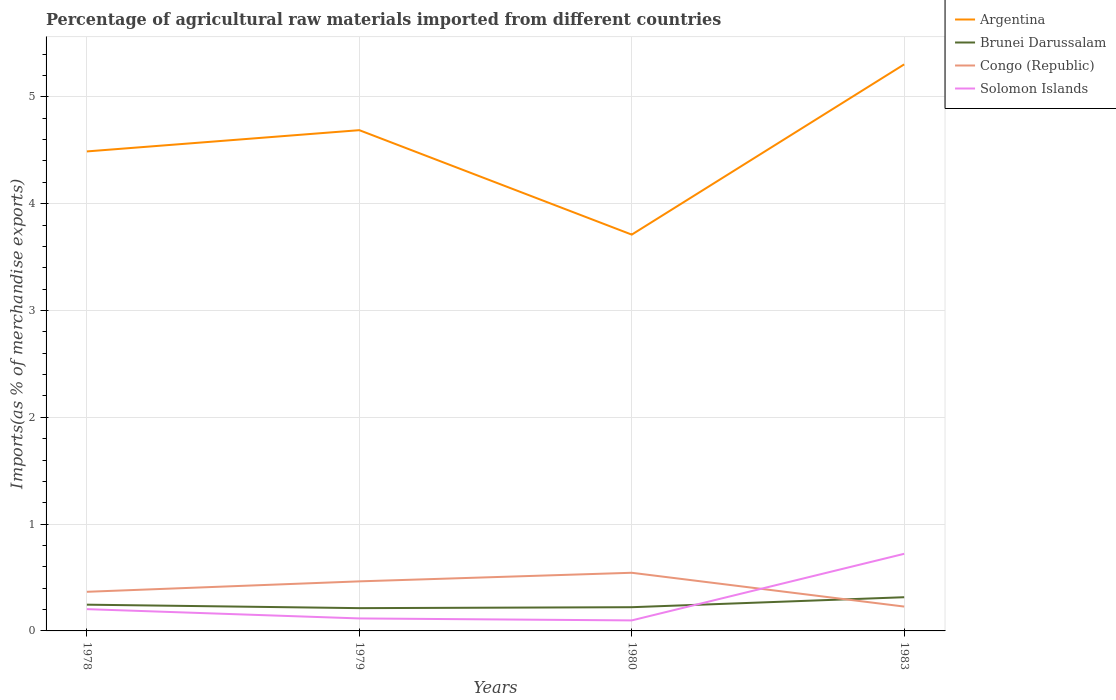How many different coloured lines are there?
Your answer should be compact. 4. Does the line corresponding to Argentina intersect with the line corresponding to Brunei Darussalam?
Offer a terse response. No. Across all years, what is the maximum percentage of imports to different countries in Solomon Islands?
Keep it short and to the point. 0.1. In which year was the percentage of imports to different countries in Brunei Darussalam maximum?
Make the answer very short. 1979. What is the total percentage of imports to different countries in Argentina in the graph?
Your answer should be very brief. -1.59. What is the difference between the highest and the second highest percentage of imports to different countries in Brunei Darussalam?
Keep it short and to the point. 0.1. Is the percentage of imports to different countries in Solomon Islands strictly greater than the percentage of imports to different countries in Congo (Republic) over the years?
Ensure brevity in your answer.  No. How many years are there in the graph?
Offer a very short reply. 4. Does the graph contain any zero values?
Ensure brevity in your answer.  No. Does the graph contain grids?
Ensure brevity in your answer.  Yes. How many legend labels are there?
Offer a very short reply. 4. What is the title of the graph?
Keep it short and to the point. Percentage of agricultural raw materials imported from different countries. What is the label or title of the X-axis?
Give a very brief answer. Years. What is the label or title of the Y-axis?
Give a very brief answer. Imports(as % of merchandise exports). What is the Imports(as % of merchandise exports) in Argentina in 1978?
Offer a very short reply. 4.49. What is the Imports(as % of merchandise exports) of Brunei Darussalam in 1978?
Offer a terse response. 0.25. What is the Imports(as % of merchandise exports) in Congo (Republic) in 1978?
Keep it short and to the point. 0.37. What is the Imports(as % of merchandise exports) of Solomon Islands in 1978?
Your response must be concise. 0.2. What is the Imports(as % of merchandise exports) of Argentina in 1979?
Your answer should be very brief. 4.69. What is the Imports(as % of merchandise exports) in Brunei Darussalam in 1979?
Your answer should be compact. 0.21. What is the Imports(as % of merchandise exports) of Congo (Republic) in 1979?
Your answer should be very brief. 0.46. What is the Imports(as % of merchandise exports) in Solomon Islands in 1979?
Give a very brief answer. 0.12. What is the Imports(as % of merchandise exports) in Argentina in 1980?
Your answer should be very brief. 3.71. What is the Imports(as % of merchandise exports) of Brunei Darussalam in 1980?
Ensure brevity in your answer.  0.22. What is the Imports(as % of merchandise exports) in Congo (Republic) in 1980?
Provide a succinct answer. 0.54. What is the Imports(as % of merchandise exports) of Solomon Islands in 1980?
Offer a very short reply. 0.1. What is the Imports(as % of merchandise exports) of Argentina in 1983?
Your answer should be compact. 5.3. What is the Imports(as % of merchandise exports) of Brunei Darussalam in 1983?
Your answer should be very brief. 0.32. What is the Imports(as % of merchandise exports) of Congo (Republic) in 1983?
Make the answer very short. 0.23. What is the Imports(as % of merchandise exports) of Solomon Islands in 1983?
Offer a very short reply. 0.72. Across all years, what is the maximum Imports(as % of merchandise exports) in Argentina?
Your answer should be very brief. 5.3. Across all years, what is the maximum Imports(as % of merchandise exports) in Brunei Darussalam?
Your answer should be compact. 0.32. Across all years, what is the maximum Imports(as % of merchandise exports) of Congo (Republic)?
Ensure brevity in your answer.  0.54. Across all years, what is the maximum Imports(as % of merchandise exports) in Solomon Islands?
Give a very brief answer. 0.72. Across all years, what is the minimum Imports(as % of merchandise exports) of Argentina?
Offer a very short reply. 3.71. Across all years, what is the minimum Imports(as % of merchandise exports) in Brunei Darussalam?
Offer a very short reply. 0.21. Across all years, what is the minimum Imports(as % of merchandise exports) in Congo (Republic)?
Keep it short and to the point. 0.23. Across all years, what is the minimum Imports(as % of merchandise exports) in Solomon Islands?
Provide a short and direct response. 0.1. What is the total Imports(as % of merchandise exports) in Argentina in the graph?
Your answer should be very brief. 18.19. What is the total Imports(as % of merchandise exports) in Congo (Republic) in the graph?
Make the answer very short. 1.6. What is the total Imports(as % of merchandise exports) of Solomon Islands in the graph?
Offer a very short reply. 1.14. What is the difference between the Imports(as % of merchandise exports) in Argentina in 1978 and that in 1979?
Make the answer very short. -0.2. What is the difference between the Imports(as % of merchandise exports) in Brunei Darussalam in 1978 and that in 1979?
Your answer should be very brief. 0.03. What is the difference between the Imports(as % of merchandise exports) of Congo (Republic) in 1978 and that in 1979?
Offer a very short reply. -0.1. What is the difference between the Imports(as % of merchandise exports) of Solomon Islands in 1978 and that in 1979?
Ensure brevity in your answer.  0.09. What is the difference between the Imports(as % of merchandise exports) in Argentina in 1978 and that in 1980?
Keep it short and to the point. 0.78. What is the difference between the Imports(as % of merchandise exports) of Brunei Darussalam in 1978 and that in 1980?
Make the answer very short. 0.02. What is the difference between the Imports(as % of merchandise exports) in Congo (Republic) in 1978 and that in 1980?
Give a very brief answer. -0.18. What is the difference between the Imports(as % of merchandise exports) of Solomon Islands in 1978 and that in 1980?
Make the answer very short. 0.11. What is the difference between the Imports(as % of merchandise exports) in Argentina in 1978 and that in 1983?
Your answer should be compact. -0.81. What is the difference between the Imports(as % of merchandise exports) in Brunei Darussalam in 1978 and that in 1983?
Your answer should be compact. -0.07. What is the difference between the Imports(as % of merchandise exports) of Congo (Republic) in 1978 and that in 1983?
Offer a very short reply. 0.14. What is the difference between the Imports(as % of merchandise exports) of Solomon Islands in 1978 and that in 1983?
Offer a terse response. -0.52. What is the difference between the Imports(as % of merchandise exports) in Argentina in 1979 and that in 1980?
Provide a short and direct response. 0.98. What is the difference between the Imports(as % of merchandise exports) in Brunei Darussalam in 1979 and that in 1980?
Give a very brief answer. -0.01. What is the difference between the Imports(as % of merchandise exports) in Congo (Republic) in 1979 and that in 1980?
Your answer should be compact. -0.08. What is the difference between the Imports(as % of merchandise exports) in Solomon Islands in 1979 and that in 1980?
Offer a very short reply. 0.02. What is the difference between the Imports(as % of merchandise exports) in Argentina in 1979 and that in 1983?
Give a very brief answer. -0.62. What is the difference between the Imports(as % of merchandise exports) of Brunei Darussalam in 1979 and that in 1983?
Keep it short and to the point. -0.1. What is the difference between the Imports(as % of merchandise exports) in Congo (Republic) in 1979 and that in 1983?
Keep it short and to the point. 0.24. What is the difference between the Imports(as % of merchandise exports) in Solomon Islands in 1979 and that in 1983?
Keep it short and to the point. -0.61. What is the difference between the Imports(as % of merchandise exports) of Argentina in 1980 and that in 1983?
Offer a terse response. -1.59. What is the difference between the Imports(as % of merchandise exports) of Brunei Darussalam in 1980 and that in 1983?
Make the answer very short. -0.09. What is the difference between the Imports(as % of merchandise exports) in Congo (Republic) in 1980 and that in 1983?
Make the answer very short. 0.32. What is the difference between the Imports(as % of merchandise exports) of Solomon Islands in 1980 and that in 1983?
Provide a succinct answer. -0.62. What is the difference between the Imports(as % of merchandise exports) of Argentina in 1978 and the Imports(as % of merchandise exports) of Brunei Darussalam in 1979?
Your response must be concise. 4.28. What is the difference between the Imports(as % of merchandise exports) in Argentina in 1978 and the Imports(as % of merchandise exports) in Congo (Republic) in 1979?
Your response must be concise. 4.03. What is the difference between the Imports(as % of merchandise exports) of Argentina in 1978 and the Imports(as % of merchandise exports) of Solomon Islands in 1979?
Make the answer very short. 4.37. What is the difference between the Imports(as % of merchandise exports) of Brunei Darussalam in 1978 and the Imports(as % of merchandise exports) of Congo (Republic) in 1979?
Your answer should be compact. -0.22. What is the difference between the Imports(as % of merchandise exports) of Brunei Darussalam in 1978 and the Imports(as % of merchandise exports) of Solomon Islands in 1979?
Your answer should be very brief. 0.13. What is the difference between the Imports(as % of merchandise exports) in Congo (Republic) in 1978 and the Imports(as % of merchandise exports) in Solomon Islands in 1979?
Make the answer very short. 0.25. What is the difference between the Imports(as % of merchandise exports) of Argentina in 1978 and the Imports(as % of merchandise exports) of Brunei Darussalam in 1980?
Provide a short and direct response. 4.27. What is the difference between the Imports(as % of merchandise exports) of Argentina in 1978 and the Imports(as % of merchandise exports) of Congo (Republic) in 1980?
Your answer should be very brief. 3.95. What is the difference between the Imports(as % of merchandise exports) of Argentina in 1978 and the Imports(as % of merchandise exports) of Solomon Islands in 1980?
Offer a very short reply. 4.39. What is the difference between the Imports(as % of merchandise exports) of Brunei Darussalam in 1978 and the Imports(as % of merchandise exports) of Congo (Republic) in 1980?
Provide a succinct answer. -0.3. What is the difference between the Imports(as % of merchandise exports) of Brunei Darussalam in 1978 and the Imports(as % of merchandise exports) of Solomon Islands in 1980?
Provide a short and direct response. 0.15. What is the difference between the Imports(as % of merchandise exports) of Congo (Republic) in 1978 and the Imports(as % of merchandise exports) of Solomon Islands in 1980?
Make the answer very short. 0.27. What is the difference between the Imports(as % of merchandise exports) in Argentina in 1978 and the Imports(as % of merchandise exports) in Brunei Darussalam in 1983?
Your response must be concise. 4.17. What is the difference between the Imports(as % of merchandise exports) of Argentina in 1978 and the Imports(as % of merchandise exports) of Congo (Republic) in 1983?
Offer a terse response. 4.26. What is the difference between the Imports(as % of merchandise exports) in Argentina in 1978 and the Imports(as % of merchandise exports) in Solomon Islands in 1983?
Your response must be concise. 3.77. What is the difference between the Imports(as % of merchandise exports) in Brunei Darussalam in 1978 and the Imports(as % of merchandise exports) in Congo (Republic) in 1983?
Offer a very short reply. 0.02. What is the difference between the Imports(as % of merchandise exports) of Brunei Darussalam in 1978 and the Imports(as % of merchandise exports) of Solomon Islands in 1983?
Your answer should be very brief. -0.48. What is the difference between the Imports(as % of merchandise exports) of Congo (Republic) in 1978 and the Imports(as % of merchandise exports) of Solomon Islands in 1983?
Keep it short and to the point. -0.36. What is the difference between the Imports(as % of merchandise exports) of Argentina in 1979 and the Imports(as % of merchandise exports) of Brunei Darussalam in 1980?
Give a very brief answer. 4.47. What is the difference between the Imports(as % of merchandise exports) of Argentina in 1979 and the Imports(as % of merchandise exports) of Congo (Republic) in 1980?
Your answer should be compact. 4.14. What is the difference between the Imports(as % of merchandise exports) in Argentina in 1979 and the Imports(as % of merchandise exports) in Solomon Islands in 1980?
Ensure brevity in your answer.  4.59. What is the difference between the Imports(as % of merchandise exports) of Brunei Darussalam in 1979 and the Imports(as % of merchandise exports) of Congo (Republic) in 1980?
Offer a very short reply. -0.33. What is the difference between the Imports(as % of merchandise exports) of Brunei Darussalam in 1979 and the Imports(as % of merchandise exports) of Solomon Islands in 1980?
Provide a succinct answer. 0.11. What is the difference between the Imports(as % of merchandise exports) in Congo (Republic) in 1979 and the Imports(as % of merchandise exports) in Solomon Islands in 1980?
Ensure brevity in your answer.  0.37. What is the difference between the Imports(as % of merchandise exports) in Argentina in 1979 and the Imports(as % of merchandise exports) in Brunei Darussalam in 1983?
Provide a short and direct response. 4.37. What is the difference between the Imports(as % of merchandise exports) in Argentina in 1979 and the Imports(as % of merchandise exports) in Congo (Republic) in 1983?
Ensure brevity in your answer.  4.46. What is the difference between the Imports(as % of merchandise exports) of Argentina in 1979 and the Imports(as % of merchandise exports) of Solomon Islands in 1983?
Keep it short and to the point. 3.97. What is the difference between the Imports(as % of merchandise exports) in Brunei Darussalam in 1979 and the Imports(as % of merchandise exports) in Congo (Republic) in 1983?
Keep it short and to the point. -0.01. What is the difference between the Imports(as % of merchandise exports) of Brunei Darussalam in 1979 and the Imports(as % of merchandise exports) of Solomon Islands in 1983?
Offer a terse response. -0.51. What is the difference between the Imports(as % of merchandise exports) of Congo (Republic) in 1979 and the Imports(as % of merchandise exports) of Solomon Islands in 1983?
Provide a short and direct response. -0.26. What is the difference between the Imports(as % of merchandise exports) in Argentina in 1980 and the Imports(as % of merchandise exports) in Brunei Darussalam in 1983?
Your answer should be compact. 3.4. What is the difference between the Imports(as % of merchandise exports) in Argentina in 1980 and the Imports(as % of merchandise exports) in Congo (Republic) in 1983?
Your answer should be compact. 3.48. What is the difference between the Imports(as % of merchandise exports) in Argentina in 1980 and the Imports(as % of merchandise exports) in Solomon Islands in 1983?
Your answer should be very brief. 2.99. What is the difference between the Imports(as % of merchandise exports) in Brunei Darussalam in 1980 and the Imports(as % of merchandise exports) in Congo (Republic) in 1983?
Make the answer very short. -0.01. What is the difference between the Imports(as % of merchandise exports) of Congo (Republic) in 1980 and the Imports(as % of merchandise exports) of Solomon Islands in 1983?
Offer a very short reply. -0.18. What is the average Imports(as % of merchandise exports) of Argentina per year?
Make the answer very short. 4.55. What is the average Imports(as % of merchandise exports) in Brunei Darussalam per year?
Your response must be concise. 0.25. What is the average Imports(as % of merchandise exports) of Congo (Republic) per year?
Your response must be concise. 0.4. What is the average Imports(as % of merchandise exports) in Solomon Islands per year?
Offer a very short reply. 0.29. In the year 1978, what is the difference between the Imports(as % of merchandise exports) in Argentina and Imports(as % of merchandise exports) in Brunei Darussalam?
Keep it short and to the point. 4.24. In the year 1978, what is the difference between the Imports(as % of merchandise exports) in Argentina and Imports(as % of merchandise exports) in Congo (Republic)?
Offer a very short reply. 4.12. In the year 1978, what is the difference between the Imports(as % of merchandise exports) of Argentina and Imports(as % of merchandise exports) of Solomon Islands?
Make the answer very short. 4.29. In the year 1978, what is the difference between the Imports(as % of merchandise exports) in Brunei Darussalam and Imports(as % of merchandise exports) in Congo (Republic)?
Provide a short and direct response. -0.12. In the year 1978, what is the difference between the Imports(as % of merchandise exports) of Brunei Darussalam and Imports(as % of merchandise exports) of Solomon Islands?
Give a very brief answer. 0.04. In the year 1978, what is the difference between the Imports(as % of merchandise exports) of Congo (Republic) and Imports(as % of merchandise exports) of Solomon Islands?
Offer a terse response. 0.16. In the year 1979, what is the difference between the Imports(as % of merchandise exports) of Argentina and Imports(as % of merchandise exports) of Brunei Darussalam?
Your answer should be very brief. 4.48. In the year 1979, what is the difference between the Imports(as % of merchandise exports) in Argentina and Imports(as % of merchandise exports) in Congo (Republic)?
Provide a short and direct response. 4.22. In the year 1979, what is the difference between the Imports(as % of merchandise exports) in Argentina and Imports(as % of merchandise exports) in Solomon Islands?
Give a very brief answer. 4.57. In the year 1979, what is the difference between the Imports(as % of merchandise exports) of Brunei Darussalam and Imports(as % of merchandise exports) of Congo (Republic)?
Your answer should be very brief. -0.25. In the year 1979, what is the difference between the Imports(as % of merchandise exports) in Brunei Darussalam and Imports(as % of merchandise exports) in Solomon Islands?
Your answer should be compact. 0.1. In the year 1979, what is the difference between the Imports(as % of merchandise exports) of Congo (Republic) and Imports(as % of merchandise exports) of Solomon Islands?
Your answer should be very brief. 0.35. In the year 1980, what is the difference between the Imports(as % of merchandise exports) of Argentina and Imports(as % of merchandise exports) of Brunei Darussalam?
Offer a terse response. 3.49. In the year 1980, what is the difference between the Imports(as % of merchandise exports) in Argentina and Imports(as % of merchandise exports) in Congo (Republic)?
Provide a short and direct response. 3.17. In the year 1980, what is the difference between the Imports(as % of merchandise exports) of Argentina and Imports(as % of merchandise exports) of Solomon Islands?
Your response must be concise. 3.61. In the year 1980, what is the difference between the Imports(as % of merchandise exports) of Brunei Darussalam and Imports(as % of merchandise exports) of Congo (Republic)?
Give a very brief answer. -0.32. In the year 1980, what is the difference between the Imports(as % of merchandise exports) of Brunei Darussalam and Imports(as % of merchandise exports) of Solomon Islands?
Your answer should be very brief. 0.12. In the year 1980, what is the difference between the Imports(as % of merchandise exports) of Congo (Republic) and Imports(as % of merchandise exports) of Solomon Islands?
Your response must be concise. 0.45. In the year 1983, what is the difference between the Imports(as % of merchandise exports) in Argentina and Imports(as % of merchandise exports) in Brunei Darussalam?
Make the answer very short. 4.99. In the year 1983, what is the difference between the Imports(as % of merchandise exports) in Argentina and Imports(as % of merchandise exports) in Congo (Republic)?
Provide a short and direct response. 5.08. In the year 1983, what is the difference between the Imports(as % of merchandise exports) in Argentina and Imports(as % of merchandise exports) in Solomon Islands?
Your answer should be very brief. 4.58. In the year 1983, what is the difference between the Imports(as % of merchandise exports) in Brunei Darussalam and Imports(as % of merchandise exports) in Congo (Republic)?
Ensure brevity in your answer.  0.09. In the year 1983, what is the difference between the Imports(as % of merchandise exports) of Brunei Darussalam and Imports(as % of merchandise exports) of Solomon Islands?
Your answer should be very brief. -0.41. In the year 1983, what is the difference between the Imports(as % of merchandise exports) of Congo (Republic) and Imports(as % of merchandise exports) of Solomon Islands?
Make the answer very short. -0.49. What is the ratio of the Imports(as % of merchandise exports) of Argentina in 1978 to that in 1979?
Keep it short and to the point. 0.96. What is the ratio of the Imports(as % of merchandise exports) of Brunei Darussalam in 1978 to that in 1979?
Your response must be concise. 1.15. What is the ratio of the Imports(as % of merchandise exports) of Congo (Republic) in 1978 to that in 1979?
Make the answer very short. 0.79. What is the ratio of the Imports(as % of merchandise exports) of Solomon Islands in 1978 to that in 1979?
Your answer should be compact. 1.74. What is the ratio of the Imports(as % of merchandise exports) in Argentina in 1978 to that in 1980?
Provide a short and direct response. 1.21. What is the ratio of the Imports(as % of merchandise exports) in Brunei Darussalam in 1978 to that in 1980?
Your response must be concise. 1.11. What is the ratio of the Imports(as % of merchandise exports) in Congo (Republic) in 1978 to that in 1980?
Ensure brevity in your answer.  0.67. What is the ratio of the Imports(as % of merchandise exports) in Solomon Islands in 1978 to that in 1980?
Provide a short and direct response. 2.07. What is the ratio of the Imports(as % of merchandise exports) in Argentina in 1978 to that in 1983?
Ensure brevity in your answer.  0.85. What is the ratio of the Imports(as % of merchandise exports) of Brunei Darussalam in 1978 to that in 1983?
Provide a succinct answer. 0.78. What is the ratio of the Imports(as % of merchandise exports) in Congo (Republic) in 1978 to that in 1983?
Provide a succinct answer. 1.61. What is the ratio of the Imports(as % of merchandise exports) in Solomon Islands in 1978 to that in 1983?
Keep it short and to the point. 0.28. What is the ratio of the Imports(as % of merchandise exports) of Argentina in 1979 to that in 1980?
Your response must be concise. 1.26. What is the ratio of the Imports(as % of merchandise exports) in Brunei Darussalam in 1979 to that in 1980?
Your response must be concise. 0.96. What is the ratio of the Imports(as % of merchandise exports) of Congo (Republic) in 1979 to that in 1980?
Provide a succinct answer. 0.85. What is the ratio of the Imports(as % of merchandise exports) in Solomon Islands in 1979 to that in 1980?
Provide a short and direct response. 1.19. What is the ratio of the Imports(as % of merchandise exports) of Argentina in 1979 to that in 1983?
Offer a very short reply. 0.88. What is the ratio of the Imports(as % of merchandise exports) in Brunei Darussalam in 1979 to that in 1983?
Your answer should be compact. 0.68. What is the ratio of the Imports(as % of merchandise exports) in Congo (Republic) in 1979 to that in 1983?
Your answer should be very brief. 2.04. What is the ratio of the Imports(as % of merchandise exports) in Solomon Islands in 1979 to that in 1983?
Offer a very short reply. 0.16. What is the ratio of the Imports(as % of merchandise exports) in Argentina in 1980 to that in 1983?
Offer a very short reply. 0.7. What is the ratio of the Imports(as % of merchandise exports) in Brunei Darussalam in 1980 to that in 1983?
Your response must be concise. 0.7. What is the ratio of the Imports(as % of merchandise exports) in Congo (Republic) in 1980 to that in 1983?
Give a very brief answer. 2.39. What is the ratio of the Imports(as % of merchandise exports) in Solomon Islands in 1980 to that in 1983?
Give a very brief answer. 0.14. What is the difference between the highest and the second highest Imports(as % of merchandise exports) in Argentina?
Offer a very short reply. 0.62. What is the difference between the highest and the second highest Imports(as % of merchandise exports) in Brunei Darussalam?
Your response must be concise. 0.07. What is the difference between the highest and the second highest Imports(as % of merchandise exports) in Congo (Republic)?
Provide a short and direct response. 0.08. What is the difference between the highest and the second highest Imports(as % of merchandise exports) of Solomon Islands?
Keep it short and to the point. 0.52. What is the difference between the highest and the lowest Imports(as % of merchandise exports) of Argentina?
Ensure brevity in your answer.  1.59. What is the difference between the highest and the lowest Imports(as % of merchandise exports) in Brunei Darussalam?
Your answer should be compact. 0.1. What is the difference between the highest and the lowest Imports(as % of merchandise exports) in Congo (Republic)?
Your answer should be very brief. 0.32. What is the difference between the highest and the lowest Imports(as % of merchandise exports) in Solomon Islands?
Provide a succinct answer. 0.62. 